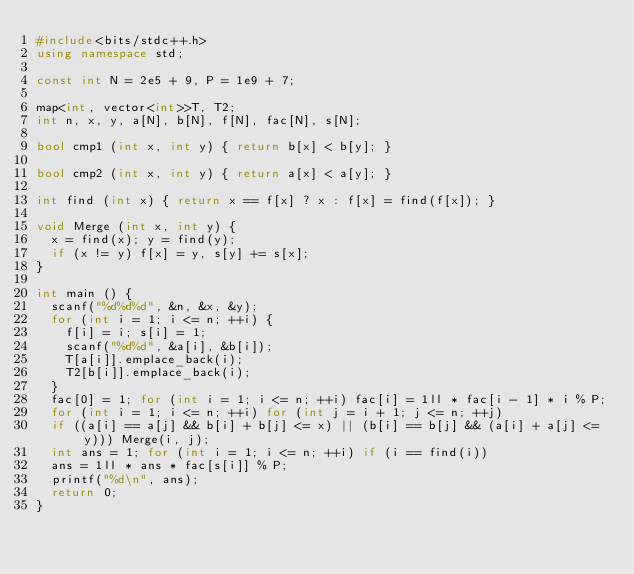Convert code to text. <code><loc_0><loc_0><loc_500><loc_500><_C++_>#include<bits/stdc++.h>
using namespace std;

const int N = 2e5 + 9, P = 1e9 + 7;

map<int, vector<int>>T, T2;
int n, x, y, a[N], b[N], f[N], fac[N], s[N];

bool cmp1 (int x, int y) { return b[x] < b[y]; }

bool cmp2 (int x, int y) { return a[x] < a[y]; }

int find (int x) { return x == f[x] ? x : f[x] = find(f[x]); }

void Merge (int x, int y) {
	x = find(x); y = find(y);
	if (x != y) f[x] = y, s[y] += s[x];
}

int main () {
	scanf("%d%d%d", &n, &x, &y);
	for (int i = 1; i <= n; ++i) {
		f[i] = i; s[i] = 1;
		scanf("%d%d", &a[i], &b[i]);
		T[a[i]].emplace_back(i);
		T2[b[i]].emplace_back(i);
	}
	fac[0] = 1; for (int i = 1; i <= n; ++i) fac[i] = 1ll * fac[i - 1] * i % P;
	for (int i = 1; i <= n; ++i) for (int j = i + 1; j <= n; ++j)
	if ((a[i] == a[j] && b[i] + b[j] <= x) || (b[i] == b[j] && (a[i] + a[j] <= y))) Merge(i, j);
	int ans = 1; for (int i = 1; i <= n; ++i) if (i == find(i))
	ans = 1ll * ans * fac[s[i]] % P;
	printf("%d\n", ans);
	return 0;
}</code> 